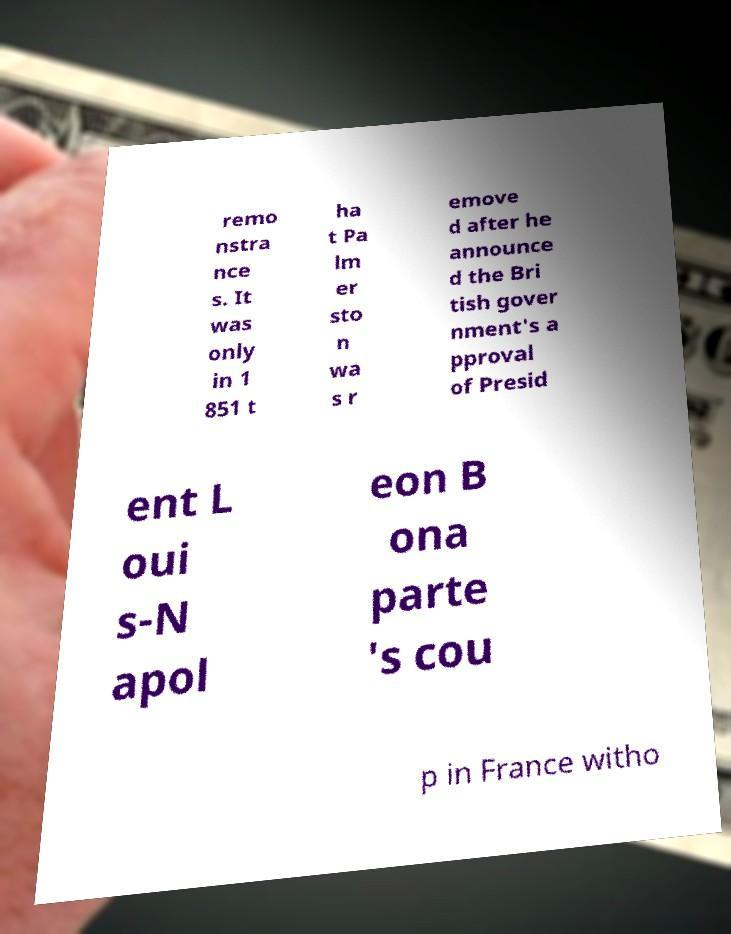Could you extract and type out the text from this image? remo nstra nce s. It was only in 1 851 t ha t Pa lm er sto n wa s r emove d after he announce d the Bri tish gover nment's a pproval of Presid ent L oui s-N apol eon B ona parte 's cou p in France witho 